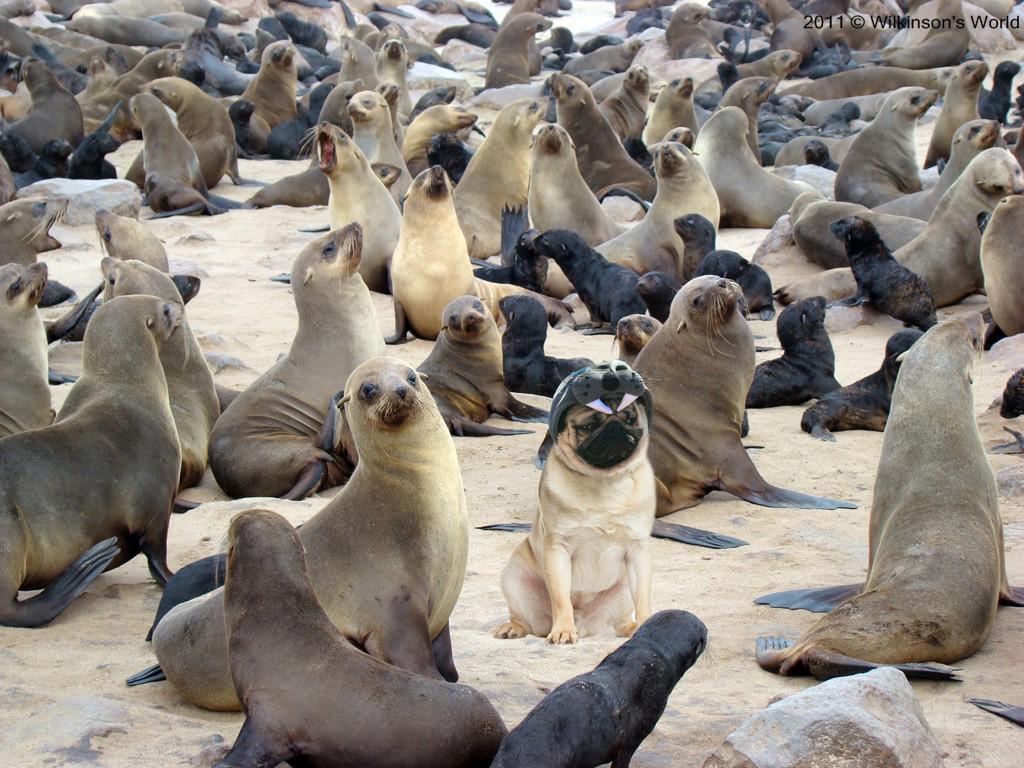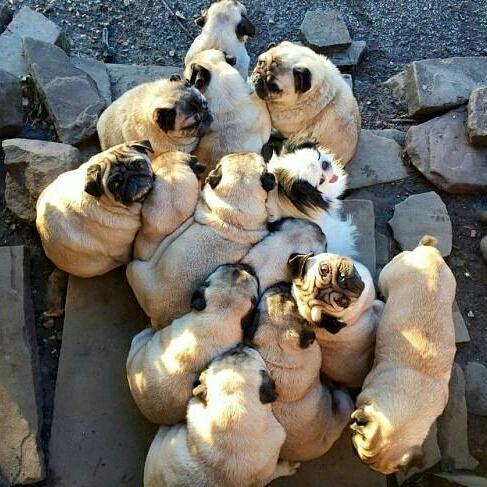The first image is the image on the left, the second image is the image on the right. Considering the images on both sides, is "Exactly one pug dog is shown in a scene with water." valid? Answer yes or no. No. The first image is the image on the left, the second image is the image on the right. Assess this claim about the two images: "The dog on the left is near an area of water.". Correct or not? Answer yes or no. No. 